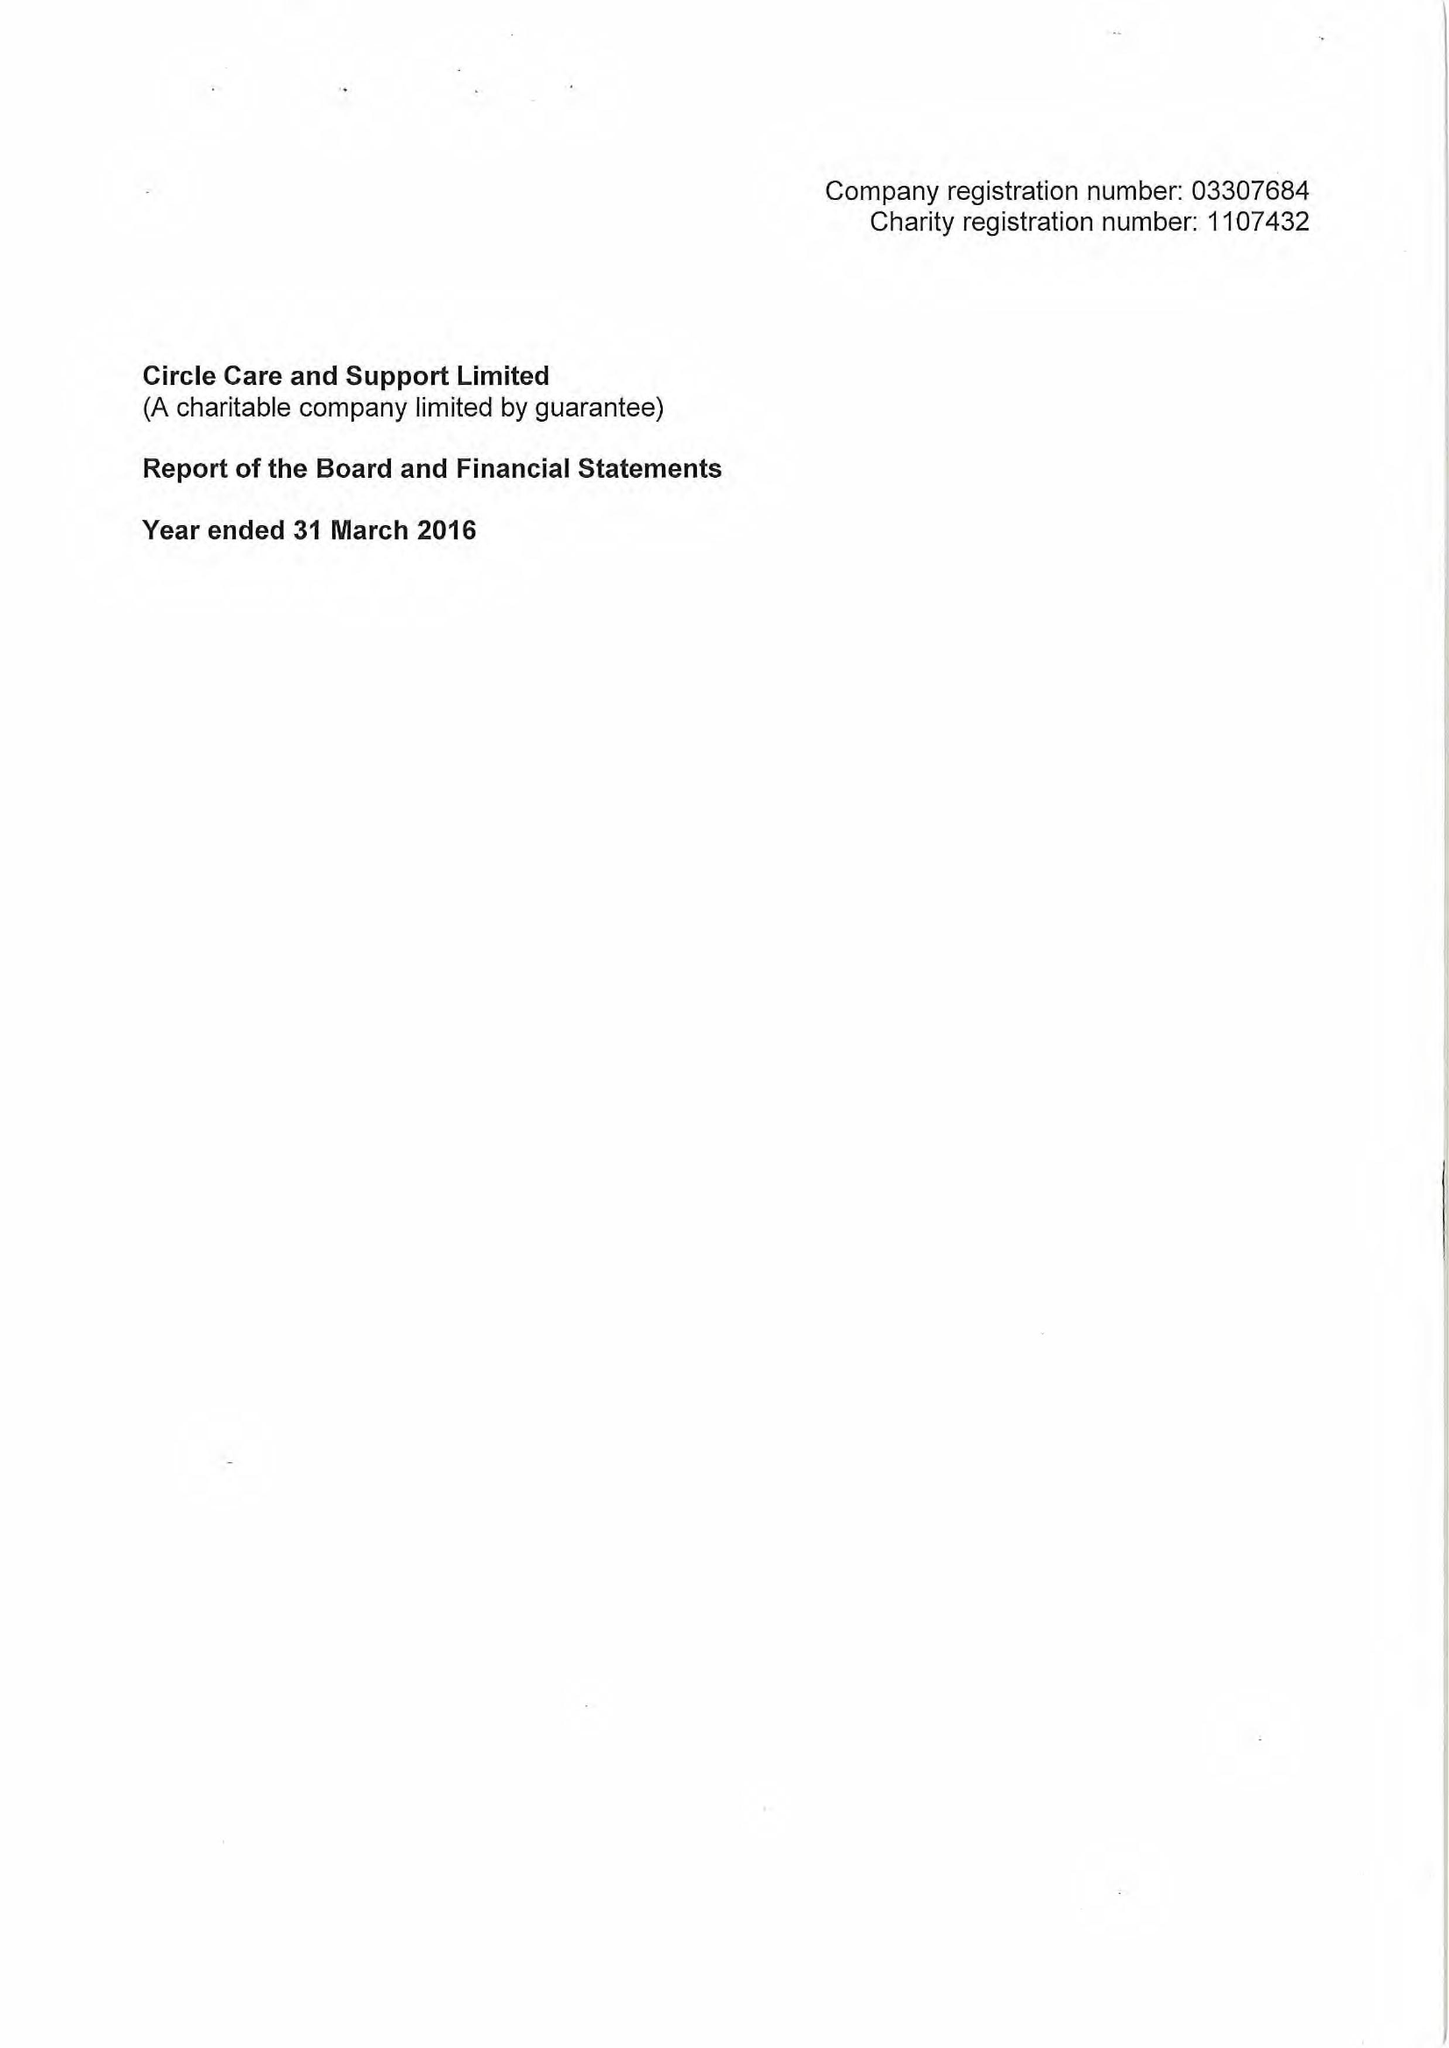What is the value for the charity_name?
Answer the question using a single word or phrase. Circle Care and Support Ltd. 